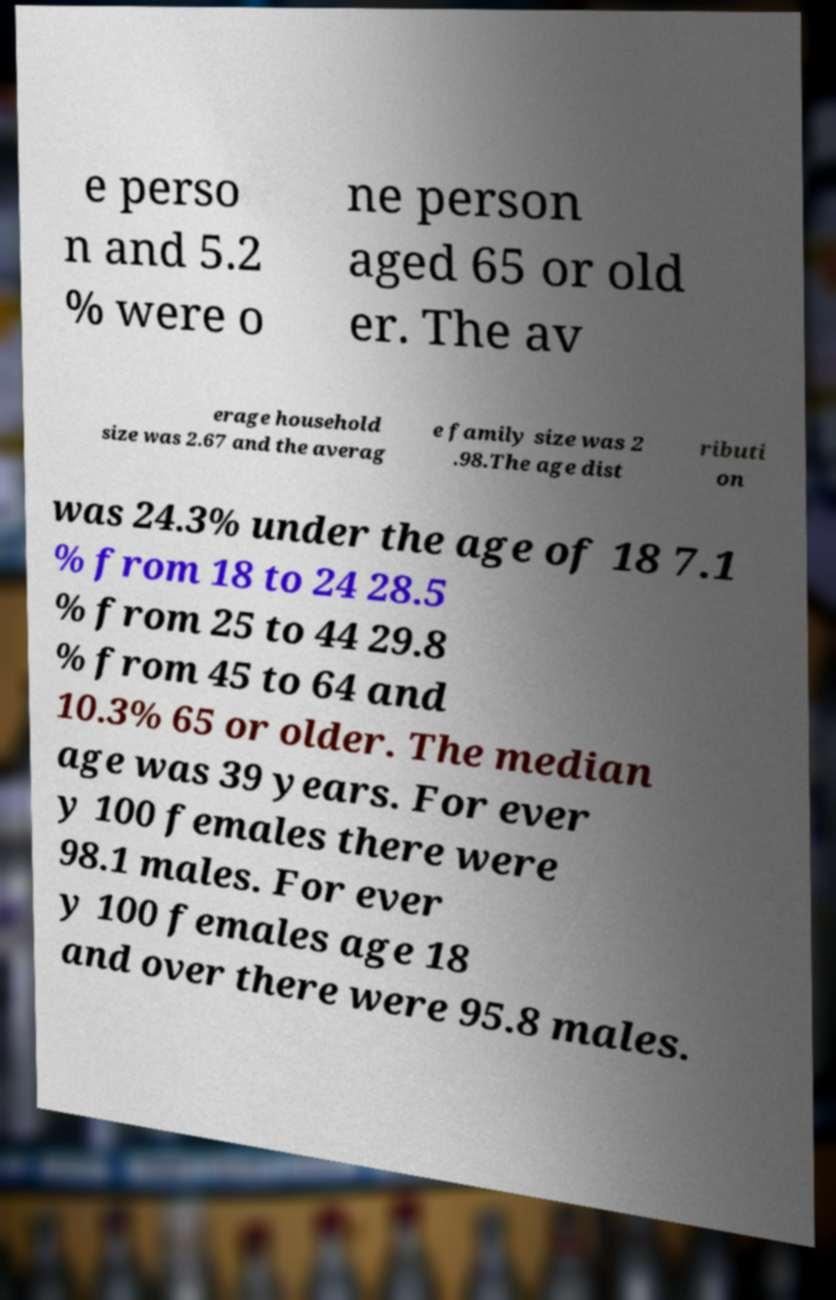Could you extract and type out the text from this image? e perso n and 5.2 % were o ne person aged 65 or old er. The av erage household size was 2.67 and the averag e family size was 2 .98.The age dist ributi on was 24.3% under the age of 18 7.1 % from 18 to 24 28.5 % from 25 to 44 29.8 % from 45 to 64 and 10.3% 65 or older. The median age was 39 years. For ever y 100 females there were 98.1 males. For ever y 100 females age 18 and over there were 95.8 males. 